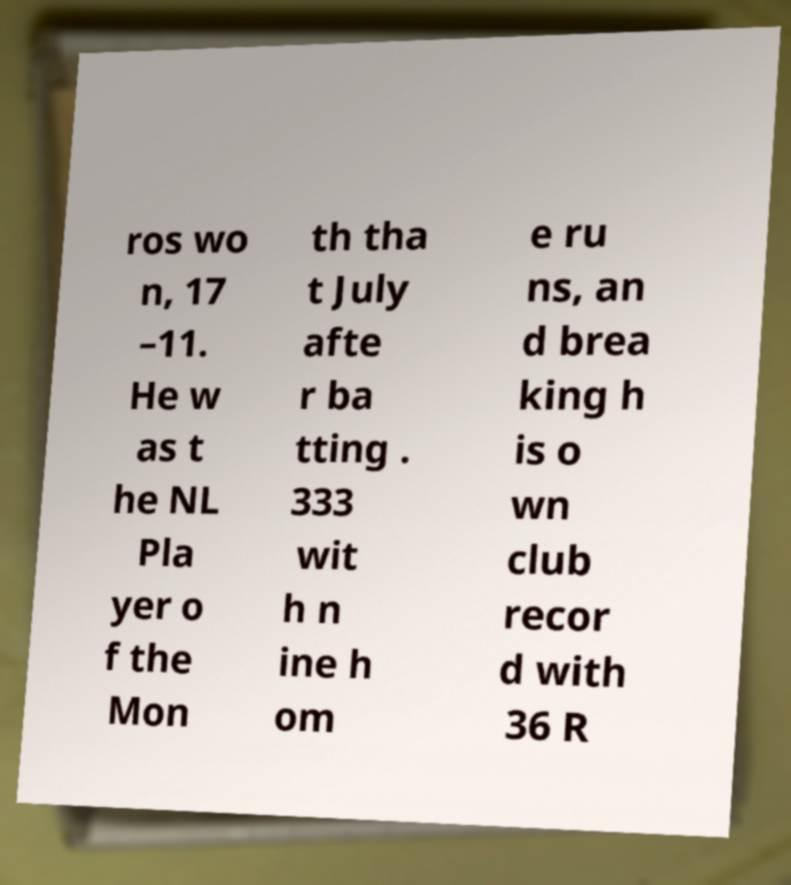Please identify and transcribe the text found in this image. ros wo n, 17 –11. He w as t he NL Pla yer o f the Mon th tha t July afte r ba tting . 333 wit h n ine h om e ru ns, an d brea king h is o wn club recor d with 36 R 